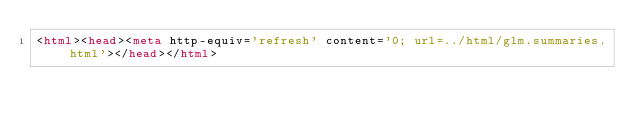Convert code to text. <code><loc_0><loc_0><loc_500><loc_500><_HTML_><html><head><meta http-equiv='refresh' content='0; url=../html/glm.summaries.html'></head></html>
</code> 